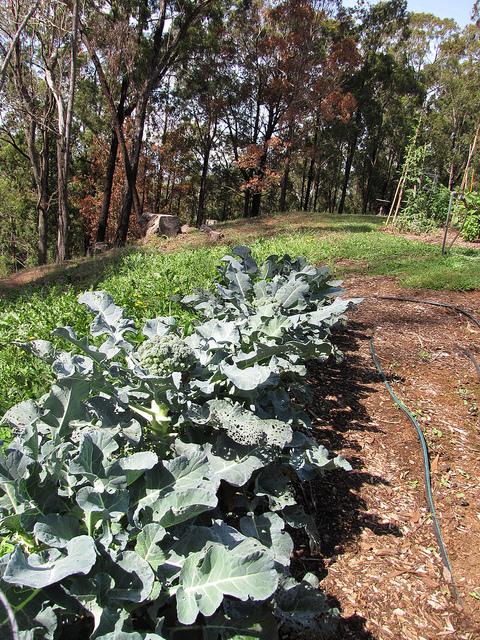What was used to create this garden?
Give a very brief answer. Seeds. Are these wildflowers?
Be succinct. No. What color is the hose?
Concise answer only. Green. What vegetable is this?
Short answer required. Cabbage. What kind of plants are these?
Write a very short answer. Broccoli. What color are the leaves?
Keep it brief. Green. What type of plants are these?
Give a very brief answer. Cabbage. What color is the grass?
Keep it brief. Green. Is this  a forest?
Be succinct. Yes. 